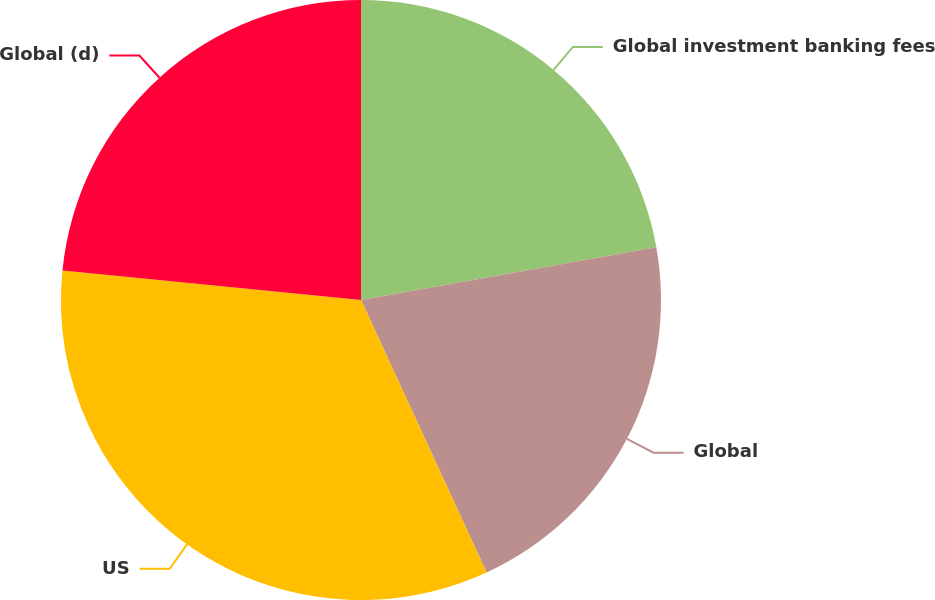<chart> <loc_0><loc_0><loc_500><loc_500><pie_chart><fcel>Global investment banking fees<fcel>Global<fcel>US<fcel>Global (d)<nl><fcel>22.19%<fcel>20.94%<fcel>33.44%<fcel>23.44%<nl></chart> 